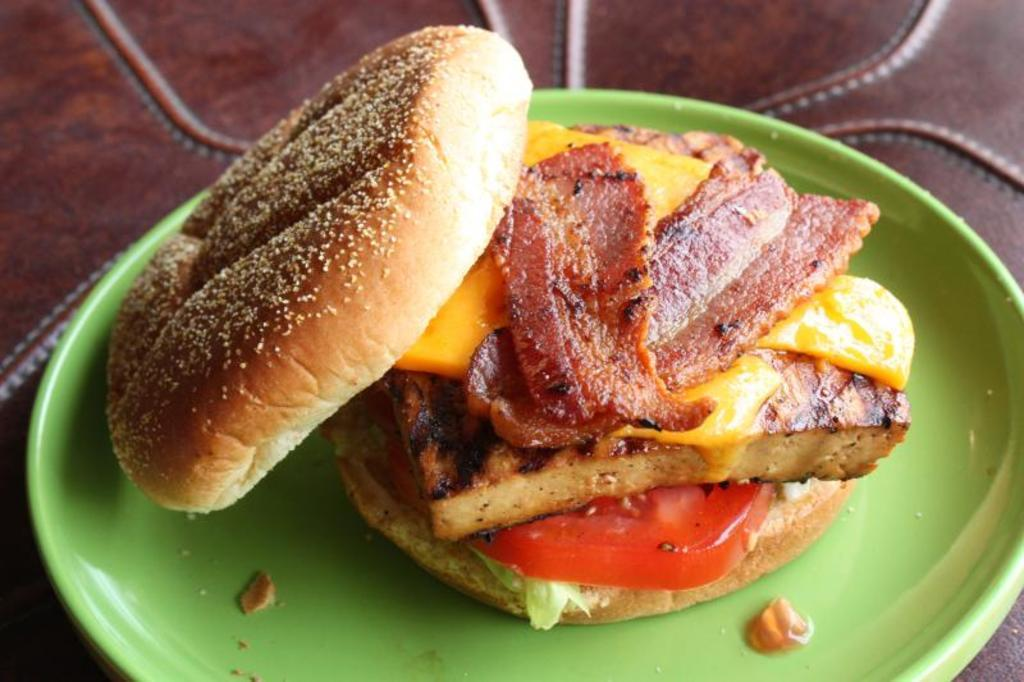What is on the plate that is visible in the image? There is a plate with food in the image. What is the plate placed on? The plate is placed on an object, but the specific object is not mentioned in the provided facts. What type of brain is visible on the plate in the image? There is no brain visible on the plate in the image; it contains food. 